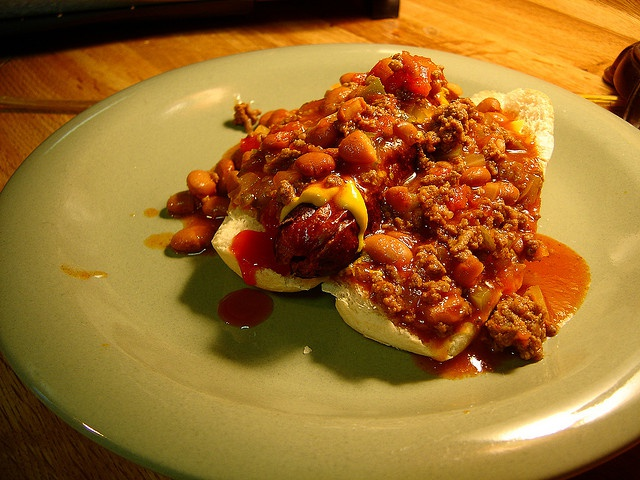Describe the objects in this image and their specific colors. I can see hot dog in black, maroon, brown, and red tones, dining table in black, orange, and brown tones, and hot dog in black, maroon, and brown tones in this image. 